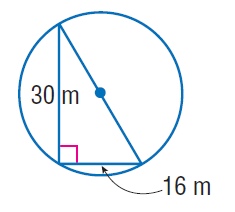Question: Find the exact circumference of the circle.
Choices:
A. 17 \pi
B. 30 \pi
C. 34 \pi
D. 64 \pi
Answer with the letter. Answer: C 